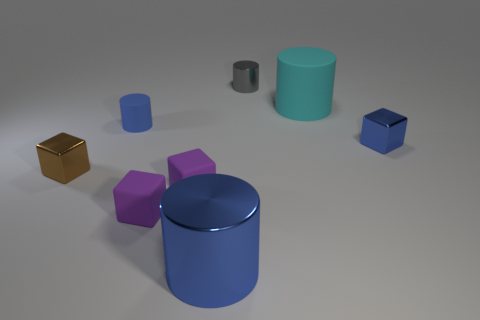Is the color of the big thing behind the small brown metallic cube the same as the tiny rubber cylinder?
Make the answer very short. No. Are there any blue metal objects that have the same shape as the large cyan matte object?
Give a very brief answer. Yes. What color is the matte cylinder that is the same size as the brown cube?
Offer a terse response. Blue. There is a blue shiny object that is to the right of the small metal cylinder; how big is it?
Ensure brevity in your answer.  Small. There is a large cylinder behind the brown metal block; are there any blue cubes behind it?
Give a very brief answer. No. Is the material of the cylinder that is in front of the tiny brown block the same as the cyan cylinder?
Keep it short and to the point. No. What number of cylinders are left of the cyan rubber thing and on the right side of the blue metallic cylinder?
Keep it short and to the point. 1. What number of tiny gray things are the same material as the brown cube?
Your answer should be very brief. 1. There is a small cylinder that is made of the same material as the tiny brown block; what is its color?
Give a very brief answer. Gray. Are there fewer blue cylinders than small yellow shiny cylinders?
Offer a very short reply. No. 